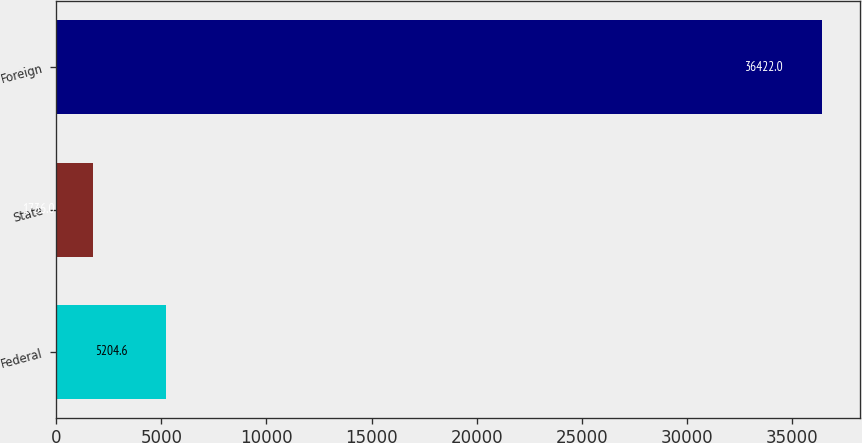<chart> <loc_0><loc_0><loc_500><loc_500><bar_chart><fcel>Federal<fcel>State<fcel>Foreign<nl><fcel>5204.6<fcel>1736<fcel>36422<nl></chart> 